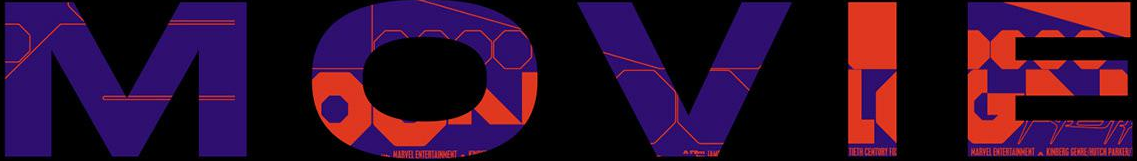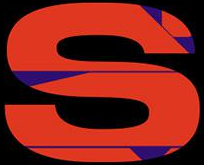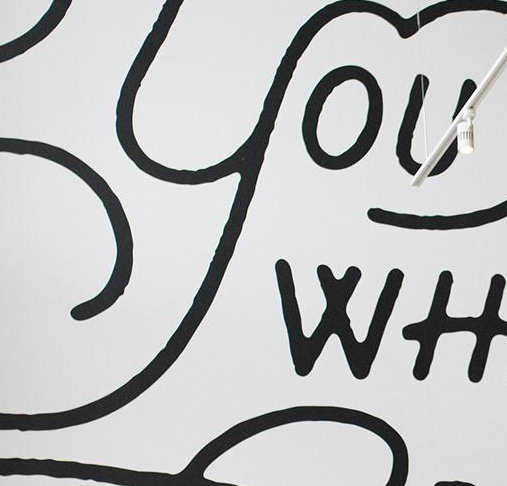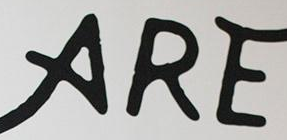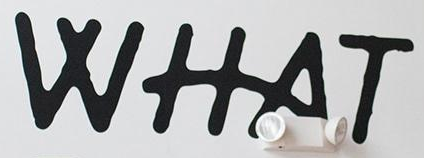What text appears in these images from left to right, separated by a semicolon? MOVIE; S; YOU; ARE; WHAT 